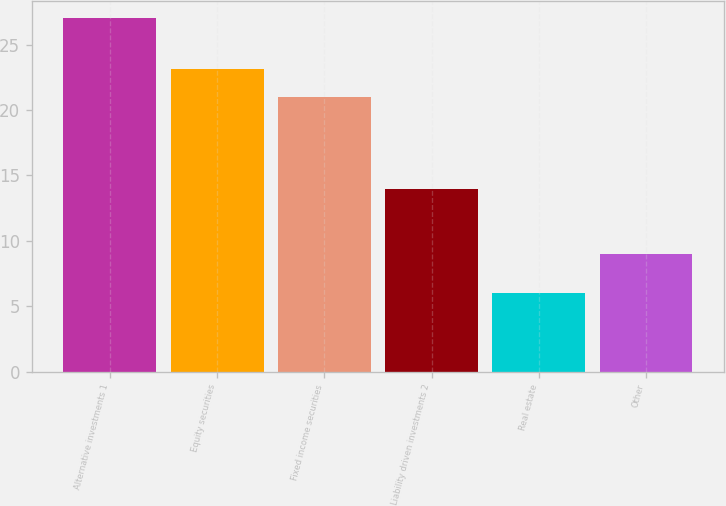Convert chart. <chart><loc_0><loc_0><loc_500><loc_500><bar_chart><fcel>Alternative investments 1<fcel>Equity securities<fcel>Fixed income securities<fcel>Liability driven investments 2<fcel>Real estate<fcel>Other<nl><fcel>27<fcel>23.1<fcel>21<fcel>14<fcel>6<fcel>9<nl></chart> 